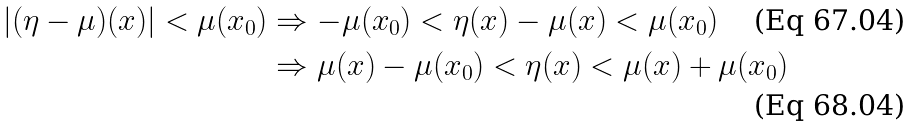<formula> <loc_0><loc_0><loc_500><loc_500>| ( \eta - \mu ) ( x ) | < \mu ( x _ { 0 } ) & \Rightarrow - \mu ( x _ { 0 } ) < \eta ( x ) - \mu ( x ) < \mu ( x _ { 0 } ) \\ & \Rightarrow \mu ( x ) - \mu ( x _ { 0 } ) < \eta ( x ) < \mu ( x ) + \mu ( x _ { 0 } )</formula> 